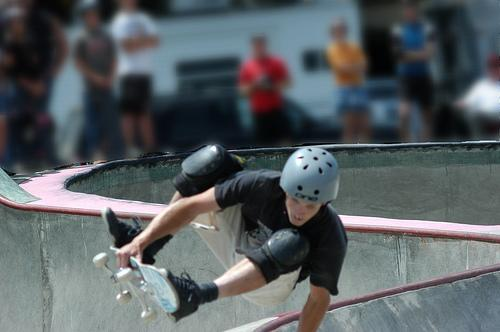How would you assess the overall quality of the image? The quality of the image is somewhat blurry, with some objects and people appearing out of focus. Point out some unique features of the skateboard. The skateboard has white wheels, silver trucks, and is being held by the skateboarder's right hand. What kind of protective gear is the skateboarder wearing? The skateboarder is wearing a helmet and knee pads. Determine any possible anomaly or oddity in the image. A possible oddity is the blurry image of a person in an orange shirt, as well as other blurred background elements. From the context of the image, what do you think is the feeling of the people watching the performance? The spectators are likely enjoying and appreciating the skateboarder's performance at the park. Can you identify the color of the helmet on the main subject? The helmet is light blue in color. What is the action being performed by the skateboarder? The skateboarder is in mid-air while executing a skateboarding trick or stunt. In a concise manner, tell me what is happening in the image. A boy is performing a skateboarding trick while wearing a helmet and knee pads, with spectators watching in the background. Describe the skateboarding area or facility seen in the image. The skateboarding facility appears to be an outdoor skate park with a circular path and metal rails. Describe the clothing of the skateboarder. The skateboarder wears a red shirt, black shorts, black knee pads, black socks, and black shoes with black laces. Can you notice the skateboarder with purple shorts? This instruction is incorrect as there is no mention of a skateboarder with purple shorts, only black shorts. Are the spectators wearing blue shirts? No, it's not mentioned in the image. The skateboard has orange trucks. This statement is misleading because the skateboard's trucks are described as silver, not orange. The skateboard has blue wheels. This instruction is misleading because the skateboard's wheels are described as white, not blue. Is the boy wearing a green helmet? The instruction is misleading because the helmet is described as light blue, not green. The person in the orange shirt is in clear focus. The instruction is misleading because the person in the orange shirt is described as being in a blurred image, not in clear focus. 